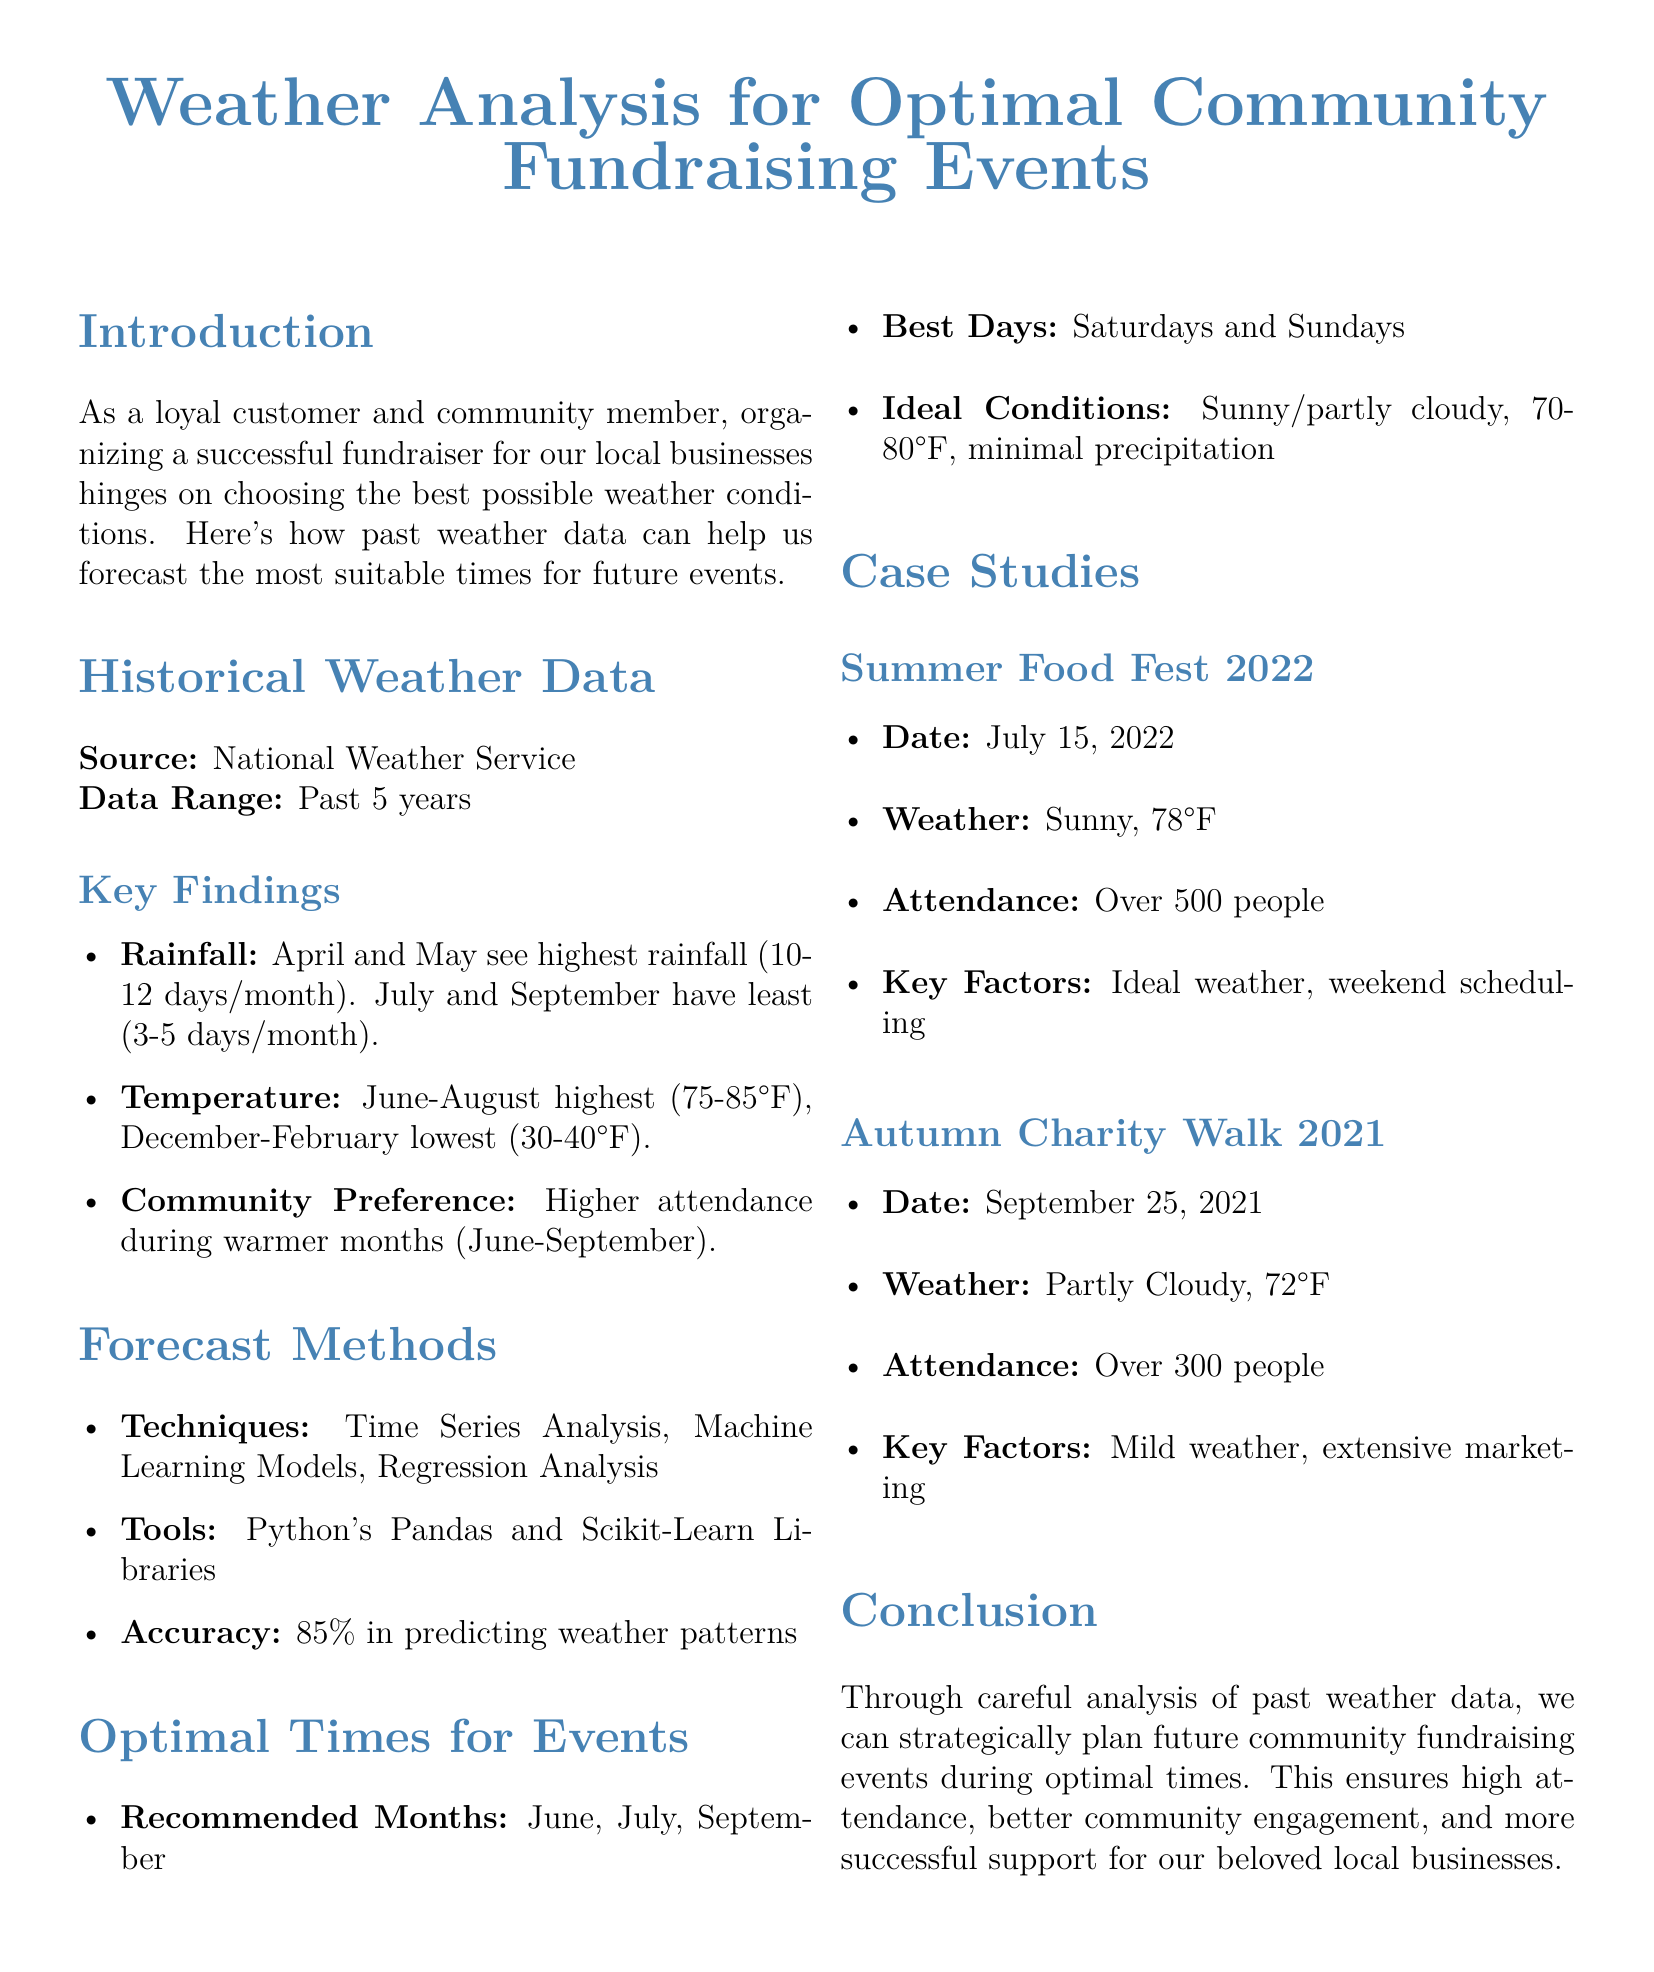What is the data range covered in the report? The data range refers to the period for which the weather data has been analyzed, which is the past 5 years.
Answer: Past 5 years What are the recommended months for events? The recommended months are identified based on favorable weather conditions, which are June, July, and September.
Answer: June, July, September What temperature range is ideal for fundraisers? The ideal temperature range for successful fundraising events is specifically stated in the document.
Answer: 70-80°F How many days in April and May see the highest rainfall? The document specifies the number of days per month that experience the highest rainfall during these months, which is 10-12 days.
Answer: 10-12 days/month What were the weather conditions during the Summer Food Fest 2022? The document lists specific weather conditions during this case study, which are sunny and 78°F.
Answer: Sunny, 78°F How does community attendance vary with temperature? The document discusses community preferences for attendance based on temperature, indicating that higher attendance occurs during warmer months.
Answer: Higher attendance during warmer months Which weekdays are identified as the best for events? The report indicates the most favorable days of the week for conducting events, specifically Saturdays and Sundays.
Answer: Saturdays and Sundays What accuracy percentage is stated for forecasting methods? The document mentions a specific accuracy rate achieved by the forecasting methods used, which is 85%.
Answer: 85% What attendance number did the Autumn Charity Walk 2021 achieve? The result of this particular fundraising event is noted in the document as a specific attendance figure.
Answer: Over 300 people 